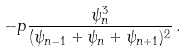Convert formula to latex. <formula><loc_0><loc_0><loc_500><loc_500>- p \frac { \psi _ { n } ^ { 3 } } { ( \psi _ { n - 1 } + \psi _ { n } + \psi _ { n + 1 } ) ^ { 2 } } \, .</formula> 